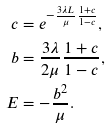Convert formula to latex. <formula><loc_0><loc_0><loc_500><loc_500>c & = e ^ { - \frac { 3 \lambda L } { \mu } \frac { 1 + c } { 1 - c } } , \\ b & = \frac { 3 \lambda } { 2 \mu } \frac { 1 + c } { 1 - c } , \\ E & = - \frac { b ^ { 2 } } { \mu } .</formula> 